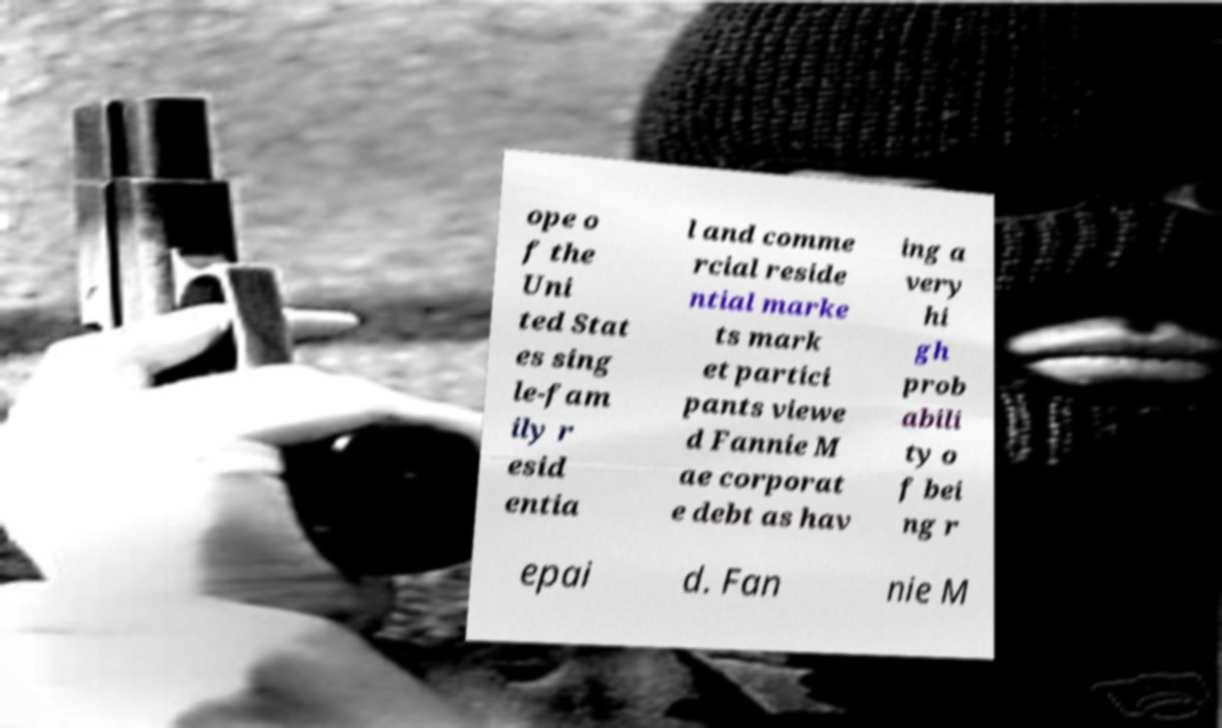Please read and relay the text visible in this image. What does it say? ope o f the Uni ted Stat es sing le-fam ily r esid entia l and comme rcial reside ntial marke ts mark et partici pants viewe d Fannie M ae corporat e debt as hav ing a very hi gh prob abili ty o f bei ng r epai d. Fan nie M 